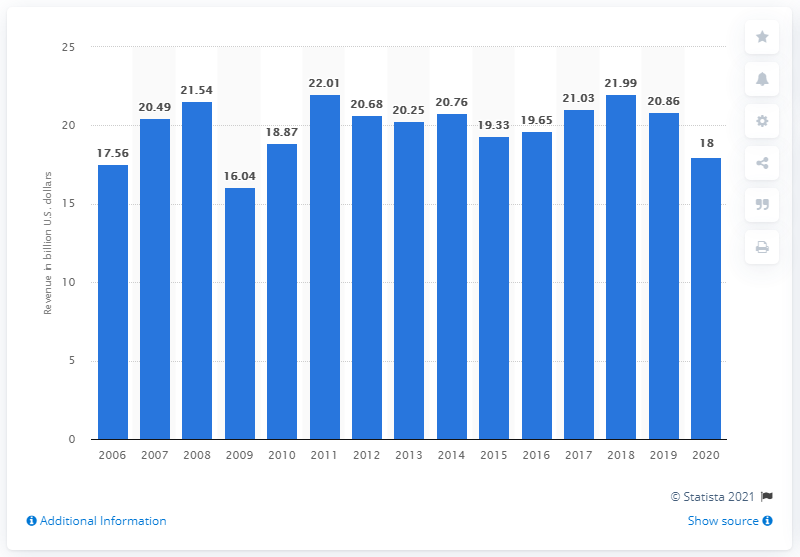Indicate a few pertinent items in this graphic. In 2020, the Manpower Group generated a significant amount of revenue in the United States, which can be specified as 18... 